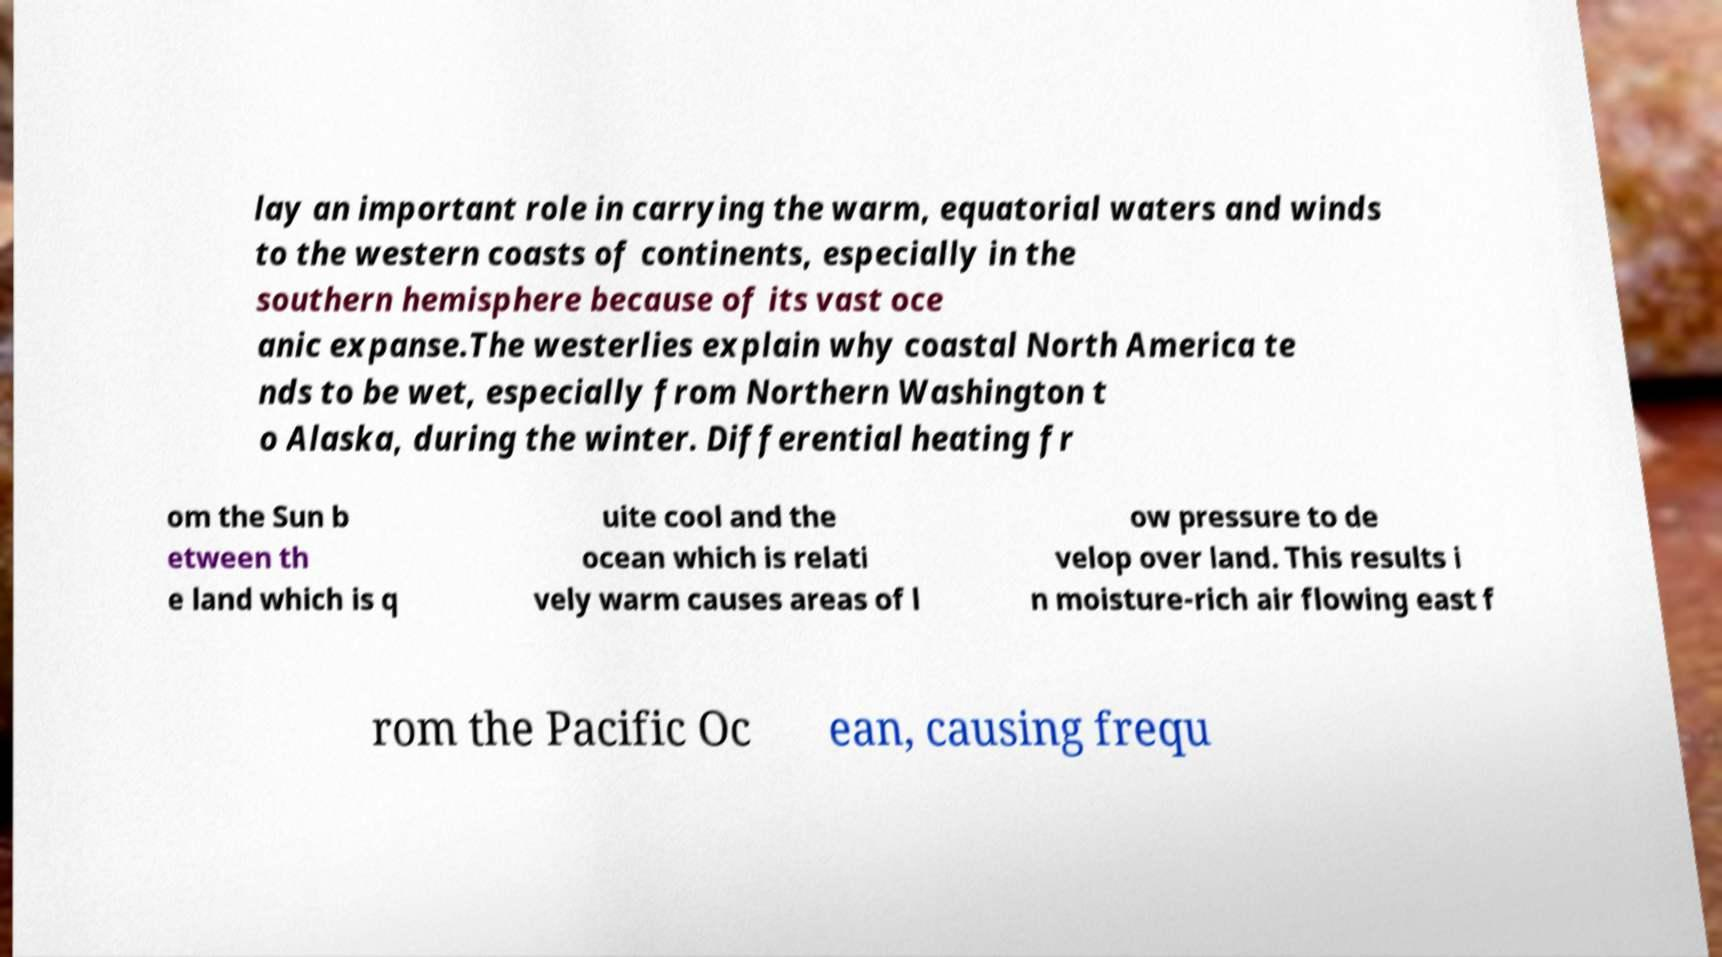I need the written content from this picture converted into text. Can you do that? lay an important role in carrying the warm, equatorial waters and winds to the western coasts of continents, especially in the southern hemisphere because of its vast oce anic expanse.The westerlies explain why coastal North America te nds to be wet, especially from Northern Washington t o Alaska, during the winter. Differential heating fr om the Sun b etween th e land which is q uite cool and the ocean which is relati vely warm causes areas of l ow pressure to de velop over land. This results i n moisture-rich air flowing east f rom the Pacific Oc ean, causing frequ 